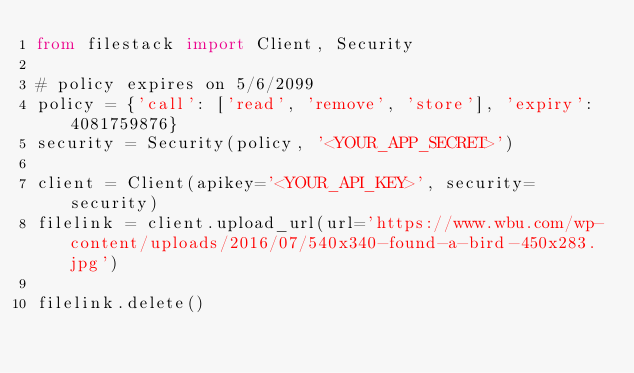Convert code to text. <code><loc_0><loc_0><loc_500><loc_500><_Python_>from filestack import Client, Security

# policy expires on 5/6/2099
policy = {'call': ['read', 'remove', 'store'], 'expiry': 4081759876}
security = Security(policy, '<YOUR_APP_SECRET>')

client = Client(apikey='<YOUR_API_KEY>', security=security)
filelink = client.upload_url(url='https://www.wbu.com/wp-content/uploads/2016/07/540x340-found-a-bird-450x283.jpg')

filelink.delete()
</code> 